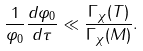Convert formula to latex. <formula><loc_0><loc_0><loc_500><loc_500>\frac { 1 } { \varphi _ { 0 } } \frac { d \varphi _ { 0 } } { d \tau } \ll \frac { \Gamma _ { \chi } ( T ) } { \Gamma _ { \chi } ( M ) } .</formula> 